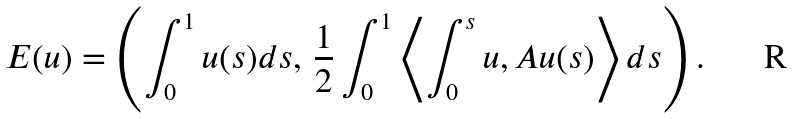Convert formula to latex. <formula><loc_0><loc_0><loc_500><loc_500>E ( u ) = \left ( \int _ { 0 } ^ { 1 } u ( s ) d s , \, \frac { 1 } { 2 } \int _ { 0 } ^ { 1 } \left \langle \int _ { 0 } ^ { s } u , A u ( s ) \right \rangle d s \right ) .</formula> 